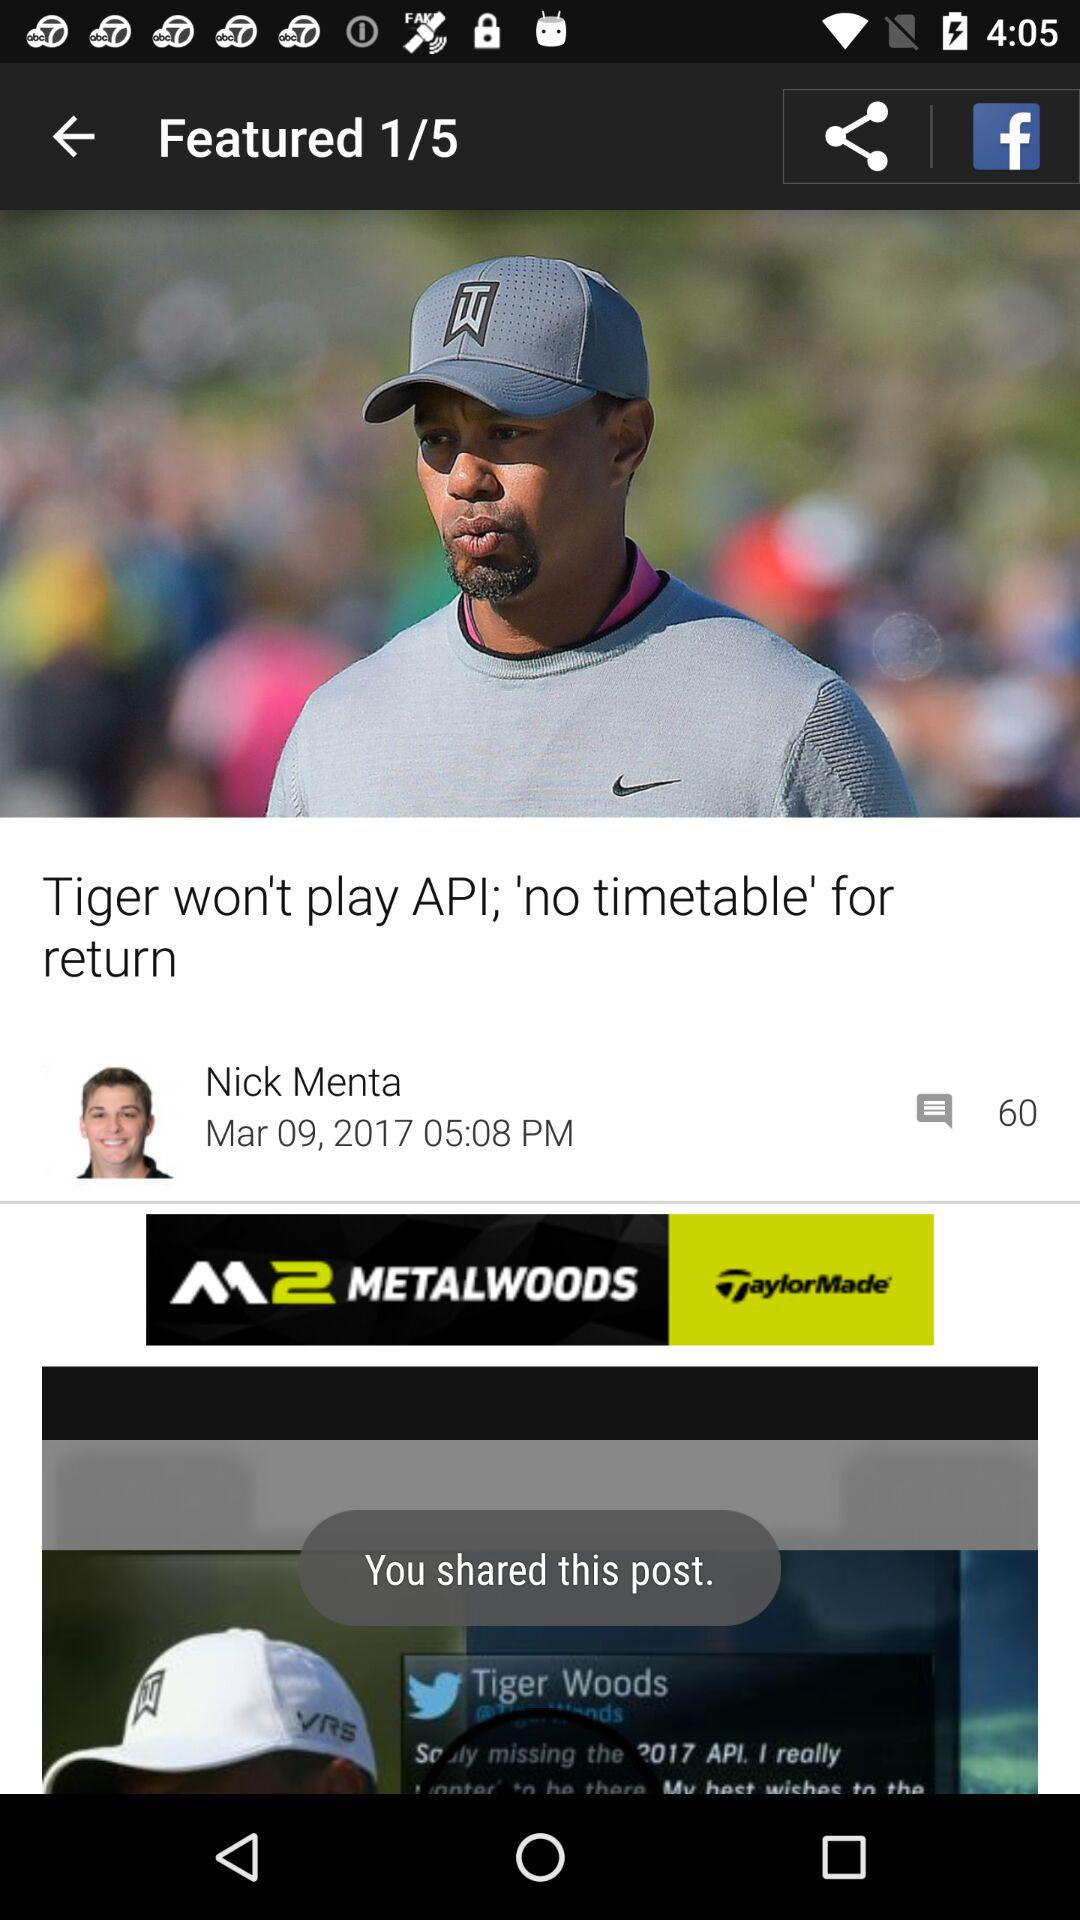What is the number of comments? The number of comments is 60. 